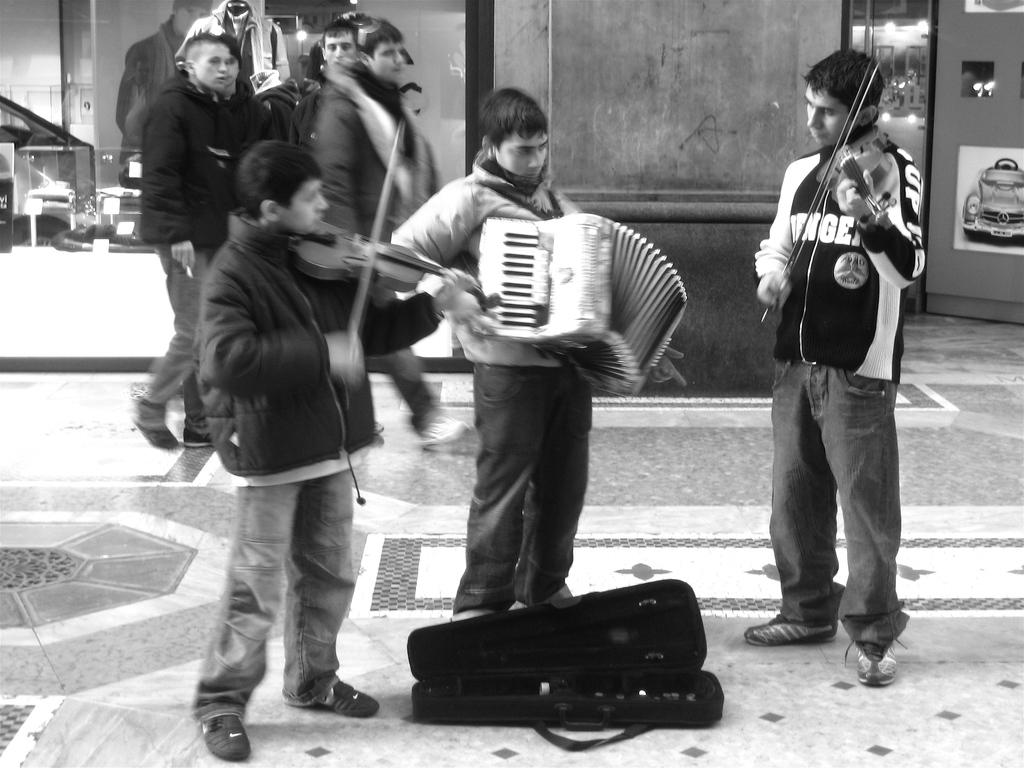What are the men in the image doing? The men in the image are playing musical instruments. What else can be seen in the image besides the men playing instruments? There are people walking and a car in the image. What type of produce is being sold in the image? There is no produce being sold in the image; the focus is on the men playing musical instruments, people walking, and the car. 